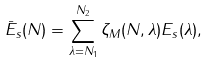<formula> <loc_0><loc_0><loc_500><loc_500>\bar { E } _ { s } ( N ) = \sum _ { \lambda = N _ { 1 } } ^ { N _ { 2 } } \zeta _ { M } ( N , \lambda ) E _ { s } ( \lambda ) ,</formula> 